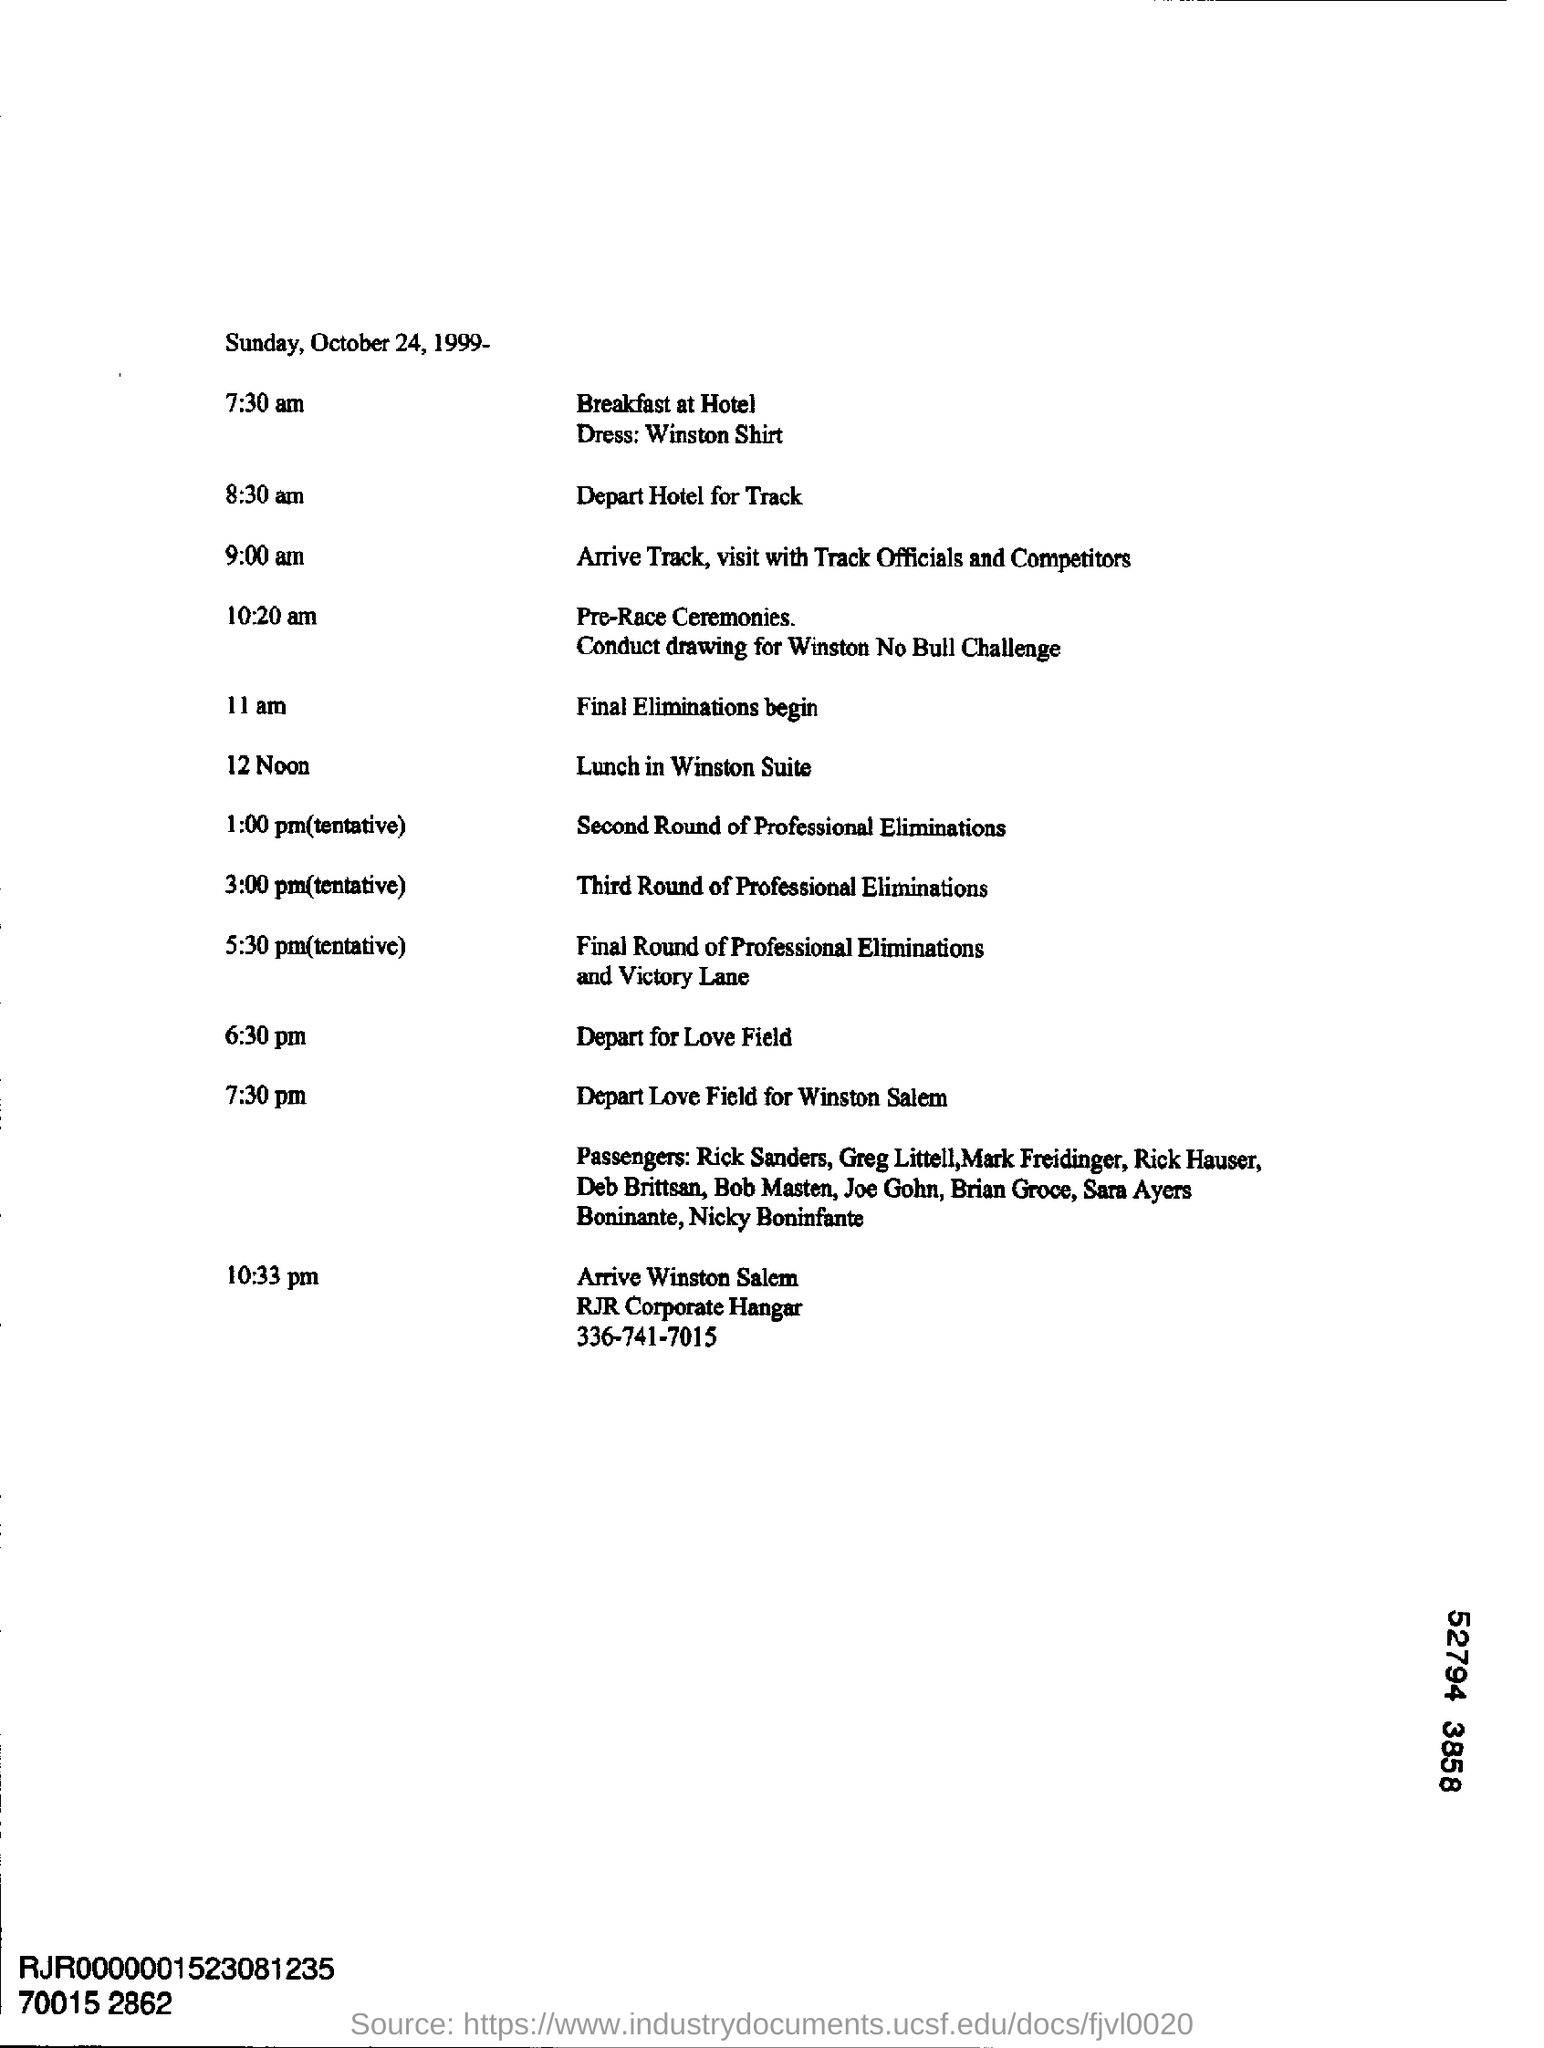What day of the week is october 24, 1999?
Provide a short and direct response. Sunday. What is the dress code mentioned in the document ?
Your answer should be compact. Winston shirt. When is the lunch in winston suite scheduled ?
Offer a terse response. 12 noon. 